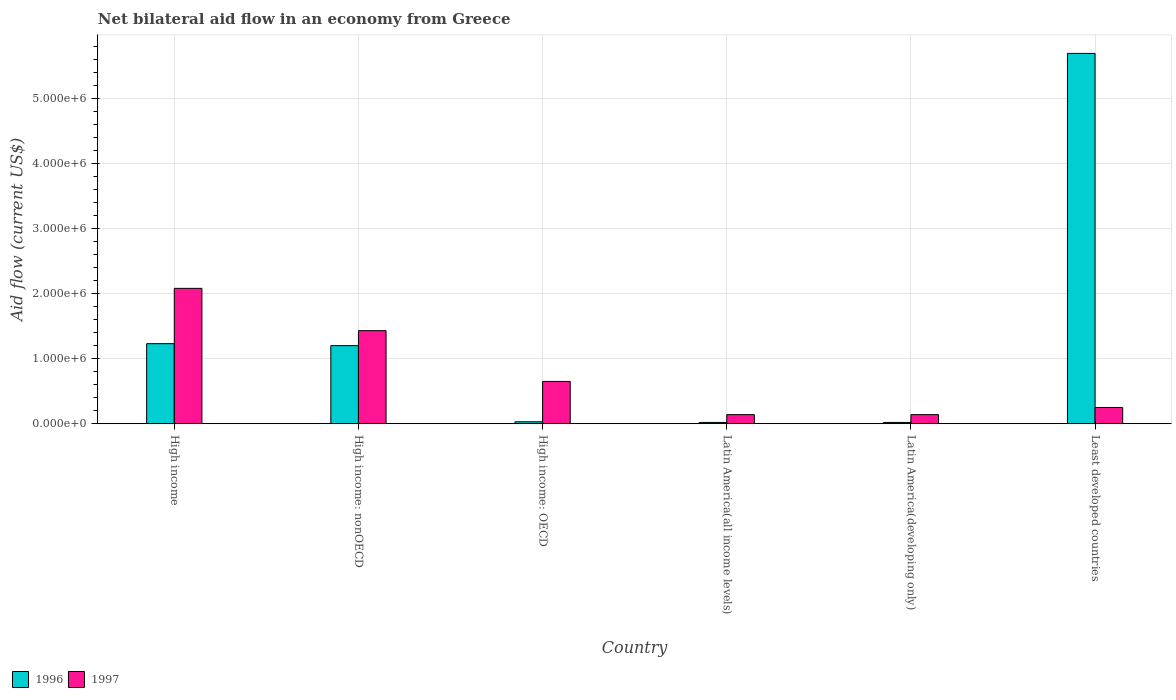Are the number of bars on each tick of the X-axis equal?
Provide a short and direct response. Yes. In how many cases, is the number of bars for a given country not equal to the number of legend labels?
Your answer should be very brief. 0. What is the net bilateral aid flow in 1997 in High income: nonOECD?
Offer a very short reply. 1.43e+06. Across all countries, what is the maximum net bilateral aid flow in 1997?
Provide a succinct answer. 2.08e+06. Across all countries, what is the minimum net bilateral aid flow in 1997?
Your response must be concise. 1.40e+05. In which country was the net bilateral aid flow in 1996 maximum?
Provide a short and direct response. Least developed countries. In which country was the net bilateral aid flow in 1997 minimum?
Provide a short and direct response. Latin America(all income levels). What is the total net bilateral aid flow in 1996 in the graph?
Your answer should be very brief. 8.19e+06. What is the difference between the net bilateral aid flow in 1996 in Latin America(all income levels) and the net bilateral aid flow in 1997 in Least developed countries?
Keep it short and to the point. -2.30e+05. What is the average net bilateral aid flow in 1997 per country?
Provide a short and direct response. 7.82e+05. In how many countries, is the net bilateral aid flow in 1996 greater than 600000 US$?
Your response must be concise. 3. What is the ratio of the net bilateral aid flow in 1997 in High income to that in Least developed countries?
Provide a succinct answer. 8.32. Is the difference between the net bilateral aid flow in 1997 in High income and Latin America(developing only) greater than the difference between the net bilateral aid flow in 1996 in High income and Latin America(developing only)?
Your answer should be compact. Yes. What is the difference between the highest and the second highest net bilateral aid flow in 1996?
Your response must be concise. 4.49e+06. What is the difference between the highest and the lowest net bilateral aid flow in 1996?
Offer a terse response. 5.67e+06. Is the sum of the net bilateral aid flow in 1997 in High income: OECD and Latin America(developing only) greater than the maximum net bilateral aid flow in 1996 across all countries?
Your answer should be very brief. No. How many countries are there in the graph?
Make the answer very short. 6. What is the difference between two consecutive major ticks on the Y-axis?
Offer a terse response. 1.00e+06. Does the graph contain any zero values?
Offer a terse response. No. What is the title of the graph?
Provide a succinct answer. Net bilateral aid flow in an economy from Greece. Does "2015" appear as one of the legend labels in the graph?
Your answer should be compact. No. What is the label or title of the Y-axis?
Keep it short and to the point. Aid flow (current US$). What is the Aid flow (current US$) of 1996 in High income?
Make the answer very short. 1.23e+06. What is the Aid flow (current US$) in 1997 in High income?
Offer a terse response. 2.08e+06. What is the Aid flow (current US$) of 1996 in High income: nonOECD?
Keep it short and to the point. 1.20e+06. What is the Aid flow (current US$) in 1997 in High income: nonOECD?
Your response must be concise. 1.43e+06. What is the Aid flow (current US$) in 1997 in High income: OECD?
Make the answer very short. 6.50e+05. What is the Aid flow (current US$) in 1997 in Latin America(all income levels)?
Give a very brief answer. 1.40e+05. What is the Aid flow (current US$) of 1996 in Latin America(developing only)?
Offer a terse response. 2.00e+04. What is the Aid flow (current US$) of 1997 in Latin America(developing only)?
Offer a terse response. 1.40e+05. What is the Aid flow (current US$) of 1996 in Least developed countries?
Provide a short and direct response. 5.69e+06. Across all countries, what is the maximum Aid flow (current US$) in 1996?
Offer a very short reply. 5.69e+06. Across all countries, what is the maximum Aid flow (current US$) of 1997?
Keep it short and to the point. 2.08e+06. Across all countries, what is the minimum Aid flow (current US$) of 1997?
Give a very brief answer. 1.40e+05. What is the total Aid flow (current US$) of 1996 in the graph?
Offer a terse response. 8.19e+06. What is the total Aid flow (current US$) in 1997 in the graph?
Keep it short and to the point. 4.69e+06. What is the difference between the Aid flow (current US$) of 1997 in High income and that in High income: nonOECD?
Provide a succinct answer. 6.50e+05. What is the difference between the Aid flow (current US$) of 1996 in High income and that in High income: OECD?
Offer a terse response. 1.20e+06. What is the difference between the Aid flow (current US$) of 1997 in High income and that in High income: OECD?
Offer a very short reply. 1.43e+06. What is the difference between the Aid flow (current US$) of 1996 in High income and that in Latin America(all income levels)?
Offer a terse response. 1.21e+06. What is the difference between the Aid flow (current US$) in 1997 in High income and that in Latin America(all income levels)?
Your answer should be very brief. 1.94e+06. What is the difference between the Aid flow (current US$) in 1996 in High income and that in Latin America(developing only)?
Provide a short and direct response. 1.21e+06. What is the difference between the Aid flow (current US$) of 1997 in High income and that in Latin America(developing only)?
Your answer should be compact. 1.94e+06. What is the difference between the Aid flow (current US$) in 1996 in High income and that in Least developed countries?
Keep it short and to the point. -4.46e+06. What is the difference between the Aid flow (current US$) of 1997 in High income and that in Least developed countries?
Give a very brief answer. 1.83e+06. What is the difference between the Aid flow (current US$) in 1996 in High income: nonOECD and that in High income: OECD?
Make the answer very short. 1.17e+06. What is the difference between the Aid flow (current US$) in 1997 in High income: nonOECD and that in High income: OECD?
Your response must be concise. 7.80e+05. What is the difference between the Aid flow (current US$) in 1996 in High income: nonOECD and that in Latin America(all income levels)?
Ensure brevity in your answer.  1.18e+06. What is the difference between the Aid flow (current US$) of 1997 in High income: nonOECD and that in Latin America(all income levels)?
Provide a succinct answer. 1.29e+06. What is the difference between the Aid flow (current US$) of 1996 in High income: nonOECD and that in Latin America(developing only)?
Your response must be concise. 1.18e+06. What is the difference between the Aid flow (current US$) of 1997 in High income: nonOECD and that in Latin America(developing only)?
Your response must be concise. 1.29e+06. What is the difference between the Aid flow (current US$) of 1996 in High income: nonOECD and that in Least developed countries?
Keep it short and to the point. -4.49e+06. What is the difference between the Aid flow (current US$) of 1997 in High income: nonOECD and that in Least developed countries?
Give a very brief answer. 1.18e+06. What is the difference between the Aid flow (current US$) in 1996 in High income: OECD and that in Latin America(all income levels)?
Provide a short and direct response. 10000. What is the difference between the Aid flow (current US$) in 1997 in High income: OECD and that in Latin America(all income levels)?
Provide a short and direct response. 5.10e+05. What is the difference between the Aid flow (current US$) in 1996 in High income: OECD and that in Latin America(developing only)?
Keep it short and to the point. 10000. What is the difference between the Aid flow (current US$) in 1997 in High income: OECD and that in Latin America(developing only)?
Give a very brief answer. 5.10e+05. What is the difference between the Aid flow (current US$) of 1996 in High income: OECD and that in Least developed countries?
Make the answer very short. -5.66e+06. What is the difference between the Aid flow (current US$) in 1997 in High income: OECD and that in Least developed countries?
Provide a short and direct response. 4.00e+05. What is the difference between the Aid flow (current US$) in 1996 in Latin America(all income levels) and that in Latin America(developing only)?
Provide a short and direct response. 0. What is the difference between the Aid flow (current US$) in 1997 in Latin America(all income levels) and that in Latin America(developing only)?
Give a very brief answer. 0. What is the difference between the Aid flow (current US$) in 1996 in Latin America(all income levels) and that in Least developed countries?
Make the answer very short. -5.67e+06. What is the difference between the Aid flow (current US$) in 1997 in Latin America(all income levels) and that in Least developed countries?
Provide a succinct answer. -1.10e+05. What is the difference between the Aid flow (current US$) in 1996 in Latin America(developing only) and that in Least developed countries?
Provide a succinct answer. -5.67e+06. What is the difference between the Aid flow (current US$) in 1996 in High income and the Aid flow (current US$) in 1997 in High income: OECD?
Provide a short and direct response. 5.80e+05. What is the difference between the Aid flow (current US$) in 1996 in High income and the Aid flow (current US$) in 1997 in Latin America(all income levels)?
Your response must be concise. 1.09e+06. What is the difference between the Aid flow (current US$) of 1996 in High income and the Aid flow (current US$) of 1997 in Latin America(developing only)?
Offer a terse response. 1.09e+06. What is the difference between the Aid flow (current US$) of 1996 in High income and the Aid flow (current US$) of 1997 in Least developed countries?
Provide a succinct answer. 9.80e+05. What is the difference between the Aid flow (current US$) of 1996 in High income: nonOECD and the Aid flow (current US$) of 1997 in Latin America(all income levels)?
Ensure brevity in your answer.  1.06e+06. What is the difference between the Aid flow (current US$) in 1996 in High income: nonOECD and the Aid flow (current US$) in 1997 in Latin America(developing only)?
Your answer should be very brief. 1.06e+06. What is the difference between the Aid flow (current US$) of 1996 in High income: nonOECD and the Aid flow (current US$) of 1997 in Least developed countries?
Provide a succinct answer. 9.50e+05. What is the difference between the Aid flow (current US$) of 1996 in High income: OECD and the Aid flow (current US$) of 1997 in Latin America(all income levels)?
Offer a very short reply. -1.10e+05. What is the difference between the Aid flow (current US$) in 1996 in High income: OECD and the Aid flow (current US$) in 1997 in Latin America(developing only)?
Make the answer very short. -1.10e+05. What is the difference between the Aid flow (current US$) of 1996 in Latin America(all income levels) and the Aid flow (current US$) of 1997 in Latin America(developing only)?
Offer a very short reply. -1.20e+05. What is the difference between the Aid flow (current US$) in 1996 in Latin America(all income levels) and the Aid flow (current US$) in 1997 in Least developed countries?
Provide a short and direct response. -2.30e+05. What is the difference between the Aid flow (current US$) in 1996 in Latin America(developing only) and the Aid flow (current US$) in 1997 in Least developed countries?
Provide a short and direct response. -2.30e+05. What is the average Aid flow (current US$) in 1996 per country?
Give a very brief answer. 1.36e+06. What is the average Aid flow (current US$) in 1997 per country?
Your answer should be very brief. 7.82e+05. What is the difference between the Aid flow (current US$) in 1996 and Aid flow (current US$) in 1997 in High income?
Give a very brief answer. -8.50e+05. What is the difference between the Aid flow (current US$) of 1996 and Aid flow (current US$) of 1997 in High income: OECD?
Provide a short and direct response. -6.20e+05. What is the difference between the Aid flow (current US$) in 1996 and Aid flow (current US$) in 1997 in Least developed countries?
Your answer should be very brief. 5.44e+06. What is the ratio of the Aid flow (current US$) in 1997 in High income to that in High income: nonOECD?
Your answer should be compact. 1.45. What is the ratio of the Aid flow (current US$) in 1996 in High income to that in High income: OECD?
Give a very brief answer. 41. What is the ratio of the Aid flow (current US$) of 1996 in High income to that in Latin America(all income levels)?
Provide a succinct answer. 61.5. What is the ratio of the Aid flow (current US$) of 1997 in High income to that in Latin America(all income levels)?
Give a very brief answer. 14.86. What is the ratio of the Aid flow (current US$) of 1996 in High income to that in Latin America(developing only)?
Provide a short and direct response. 61.5. What is the ratio of the Aid flow (current US$) in 1997 in High income to that in Latin America(developing only)?
Ensure brevity in your answer.  14.86. What is the ratio of the Aid flow (current US$) in 1996 in High income to that in Least developed countries?
Keep it short and to the point. 0.22. What is the ratio of the Aid flow (current US$) of 1997 in High income to that in Least developed countries?
Ensure brevity in your answer.  8.32. What is the ratio of the Aid flow (current US$) of 1997 in High income: nonOECD to that in Latin America(all income levels)?
Give a very brief answer. 10.21. What is the ratio of the Aid flow (current US$) in 1996 in High income: nonOECD to that in Latin America(developing only)?
Offer a terse response. 60. What is the ratio of the Aid flow (current US$) in 1997 in High income: nonOECD to that in Latin America(developing only)?
Keep it short and to the point. 10.21. What is the ratio of the Aid flow (current US$) of 1996 in High income: nonOECD to that in Least developed countries?
Your answer should be very brief. 0.21. What is the ratio of the Aid flow (current US$) in 1997 in High income: nonOECD to that in Least developed countries?
Your response must be concise. 5.72. What is the ratio of the Aid flow (current US$) of 1996 in High income: OECD to that in Latin America(all income levels)?
Your answer should be very brief. 1.5. What is the ratio of the Aid flow (current US$) of 1997 in High income: OECD to that in Latin America(all income levels)?
Offer a terse response. 4.64. What is the ratio of the Aid flow (current US$) in 1997 in High income: OECD to that in Latin America(developing only)?
Keep it short and to the point. 4.64. What is the ratio of the Aid flow (current US$) of 1996 in High income: OECD to that in Least developed countries?
Your response must be concise. 0.01. What is the ratio of the Aid flow (current US$) in 1997 in High income: OECD to that in Least developed countries?
Offer a very short reply. 2.6. What is the ratio of the Aid flow (current US$) of 1996 in Latin America(all income levels) to that in Least developed countries?
Your response must be concise. 0. What is the ratio of the Aid flow (current US$) in 1997 in Latin America(all income levels) to that in Least developed countries?
Your answer should be compact. 0.56. What is the ratio of the Aid flow (current US$) of 1996 in Latin America(developing only) to that in Least developed countries?
Your answer should be very brief. 0. What is the ratio of the Aid flow (current US$) of 1997 in Latin America(developing only) to that in Least developed countries?
Your answer should be compact. 0.56. What is the difference between the highest and the second highest Aid flow (current US$) in 1996?
Provide a short and direct response. 4.46e+06. What is the difference between the highest and the second highest Aid flow (current US$) in 1997?
Your answer should be very brief. 6.50e+05. What is the difference between the highest and the lowest Aid flow (current US$) of 1996?
Make the answer very short. 5.67e+06. What is the difference between the highest and the lowest Aid flow (current US$) of 1997?
Offer a terse response. 1.94e+06. 